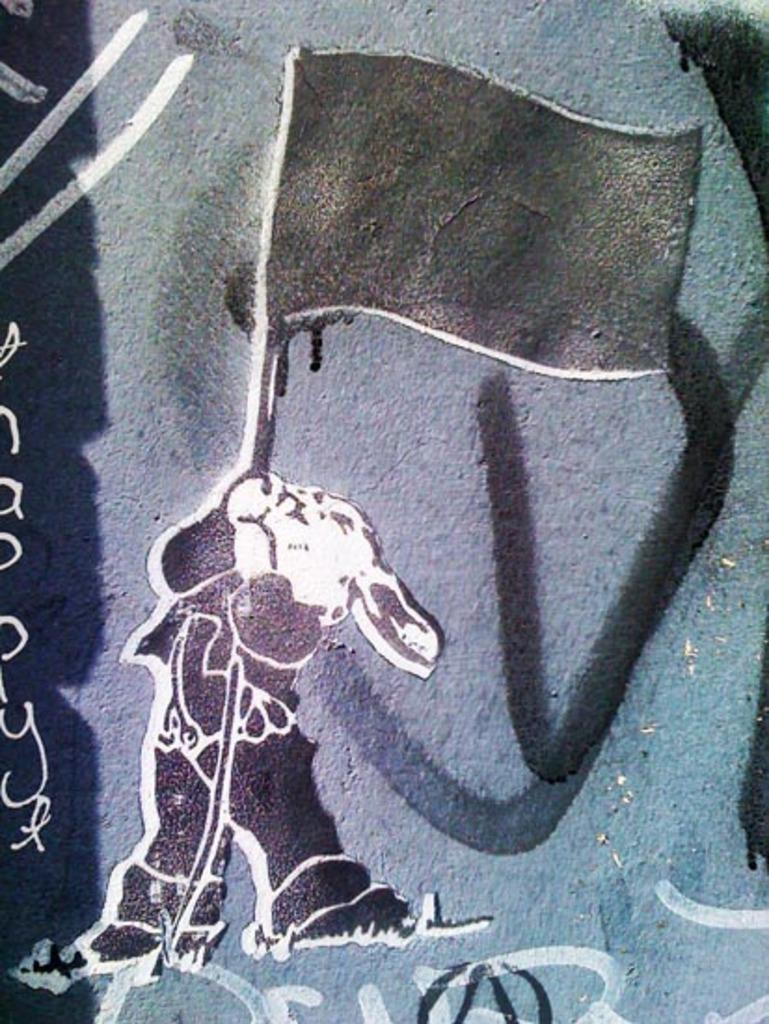What is depicted on the rock in the image? There is a painting on a rock in the image, featuring a rabbit. What is the rabbit holding in the painting? The rabbit is holding a flag in the painting. What type of cherry is being used to paint the rabbit in the image? There is no cherry present in the image, as the painting is already complete. 